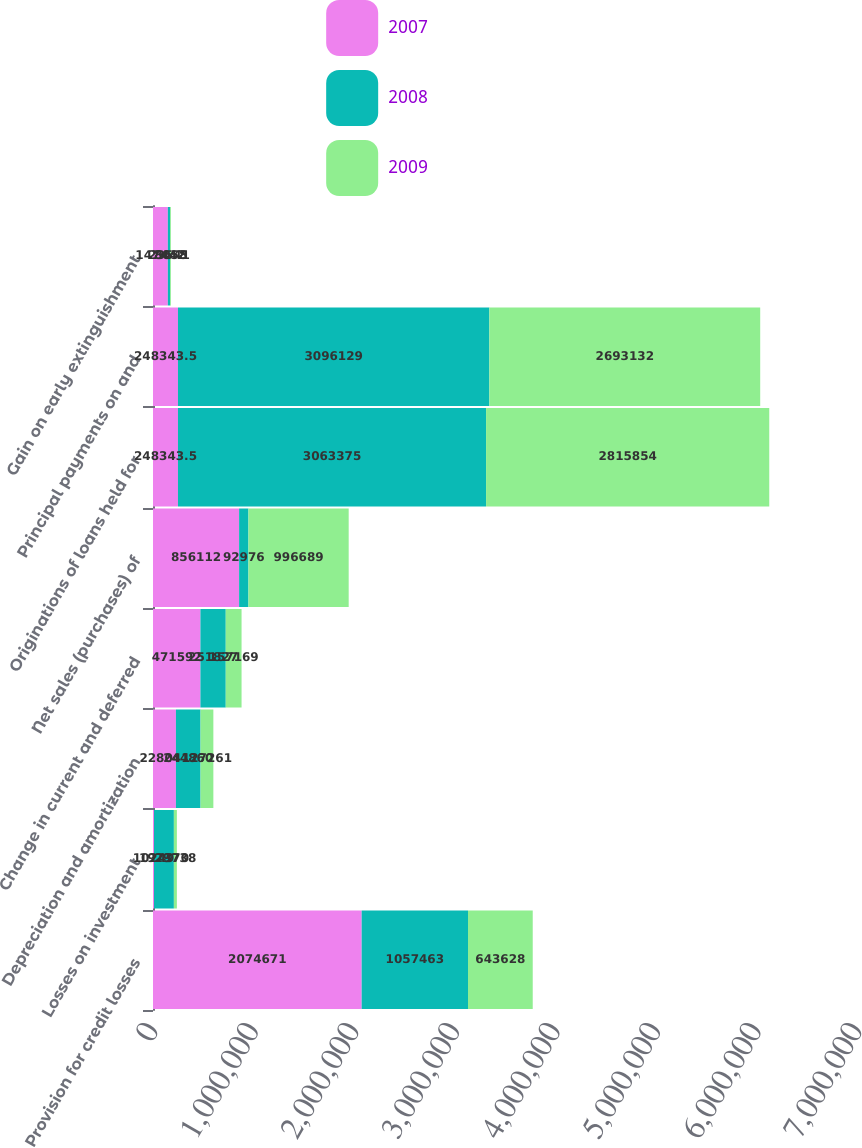<chart> <loc_0><loc_0><loc_500><loc_500><stacked_bar_chart><ecel><fcel>Provision for credit losses<fcel>Losses on investment<fcel>Depreciation and amortization<fcel>Change in current and deferred<fcel>Net sales (purchases) of<fcel>Originations of loans held for<fcel>Principal payments on and<fcel>Gain on early extinguishment<nl><fcel>2007<fcel>2.07467e+06<fcel>10249<fcel>228041<fcel>471592<fcel>856112<fcel>248344<fcel>248344<fcel>147442<nl><fcel>2008<fcel>1.05746e+06<fcel>197370<fcel>244860<fcel>251827<fcel>92976<fcel>3.06338e+06<fcel>3.09613e+06<fcel>23541<nl><fcel>2009<fcel>643628<fcel>29738<fcel>127261<fcel>157169<fcel>996689<fcel>2.81585e+06<fcel>2.69313e+06<fcel>8058<nl></chart> 